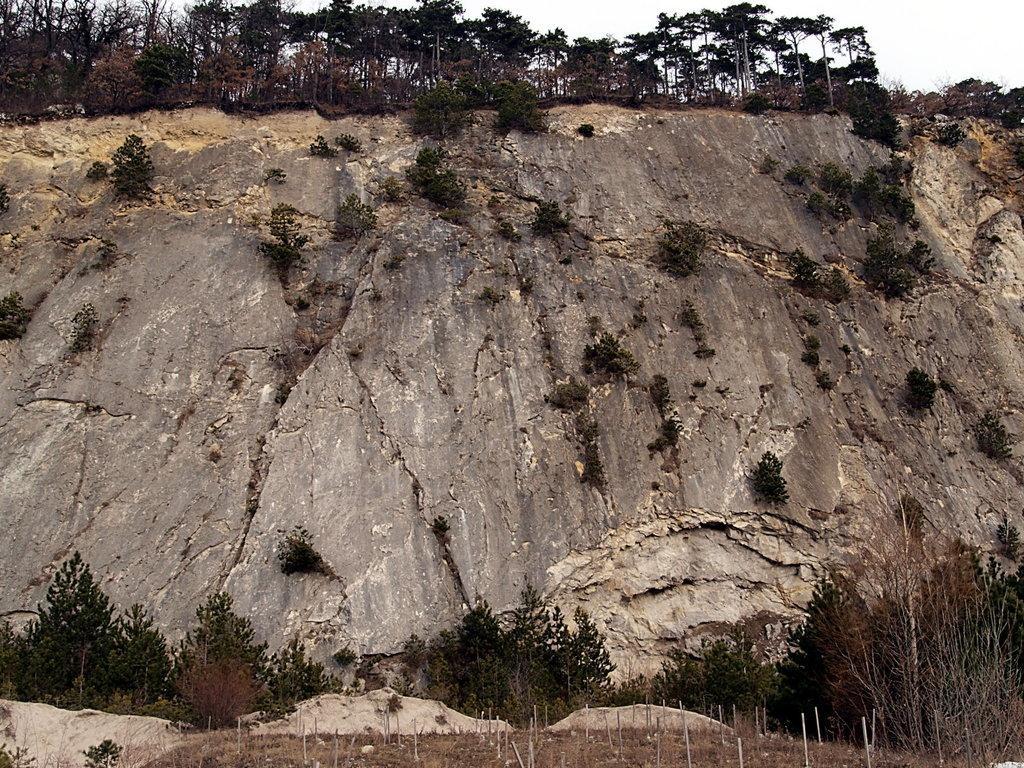Describe this image in one or two sentences. In this image we can see a group of trees, the hill, rocks, plants, some poles and the sky. 